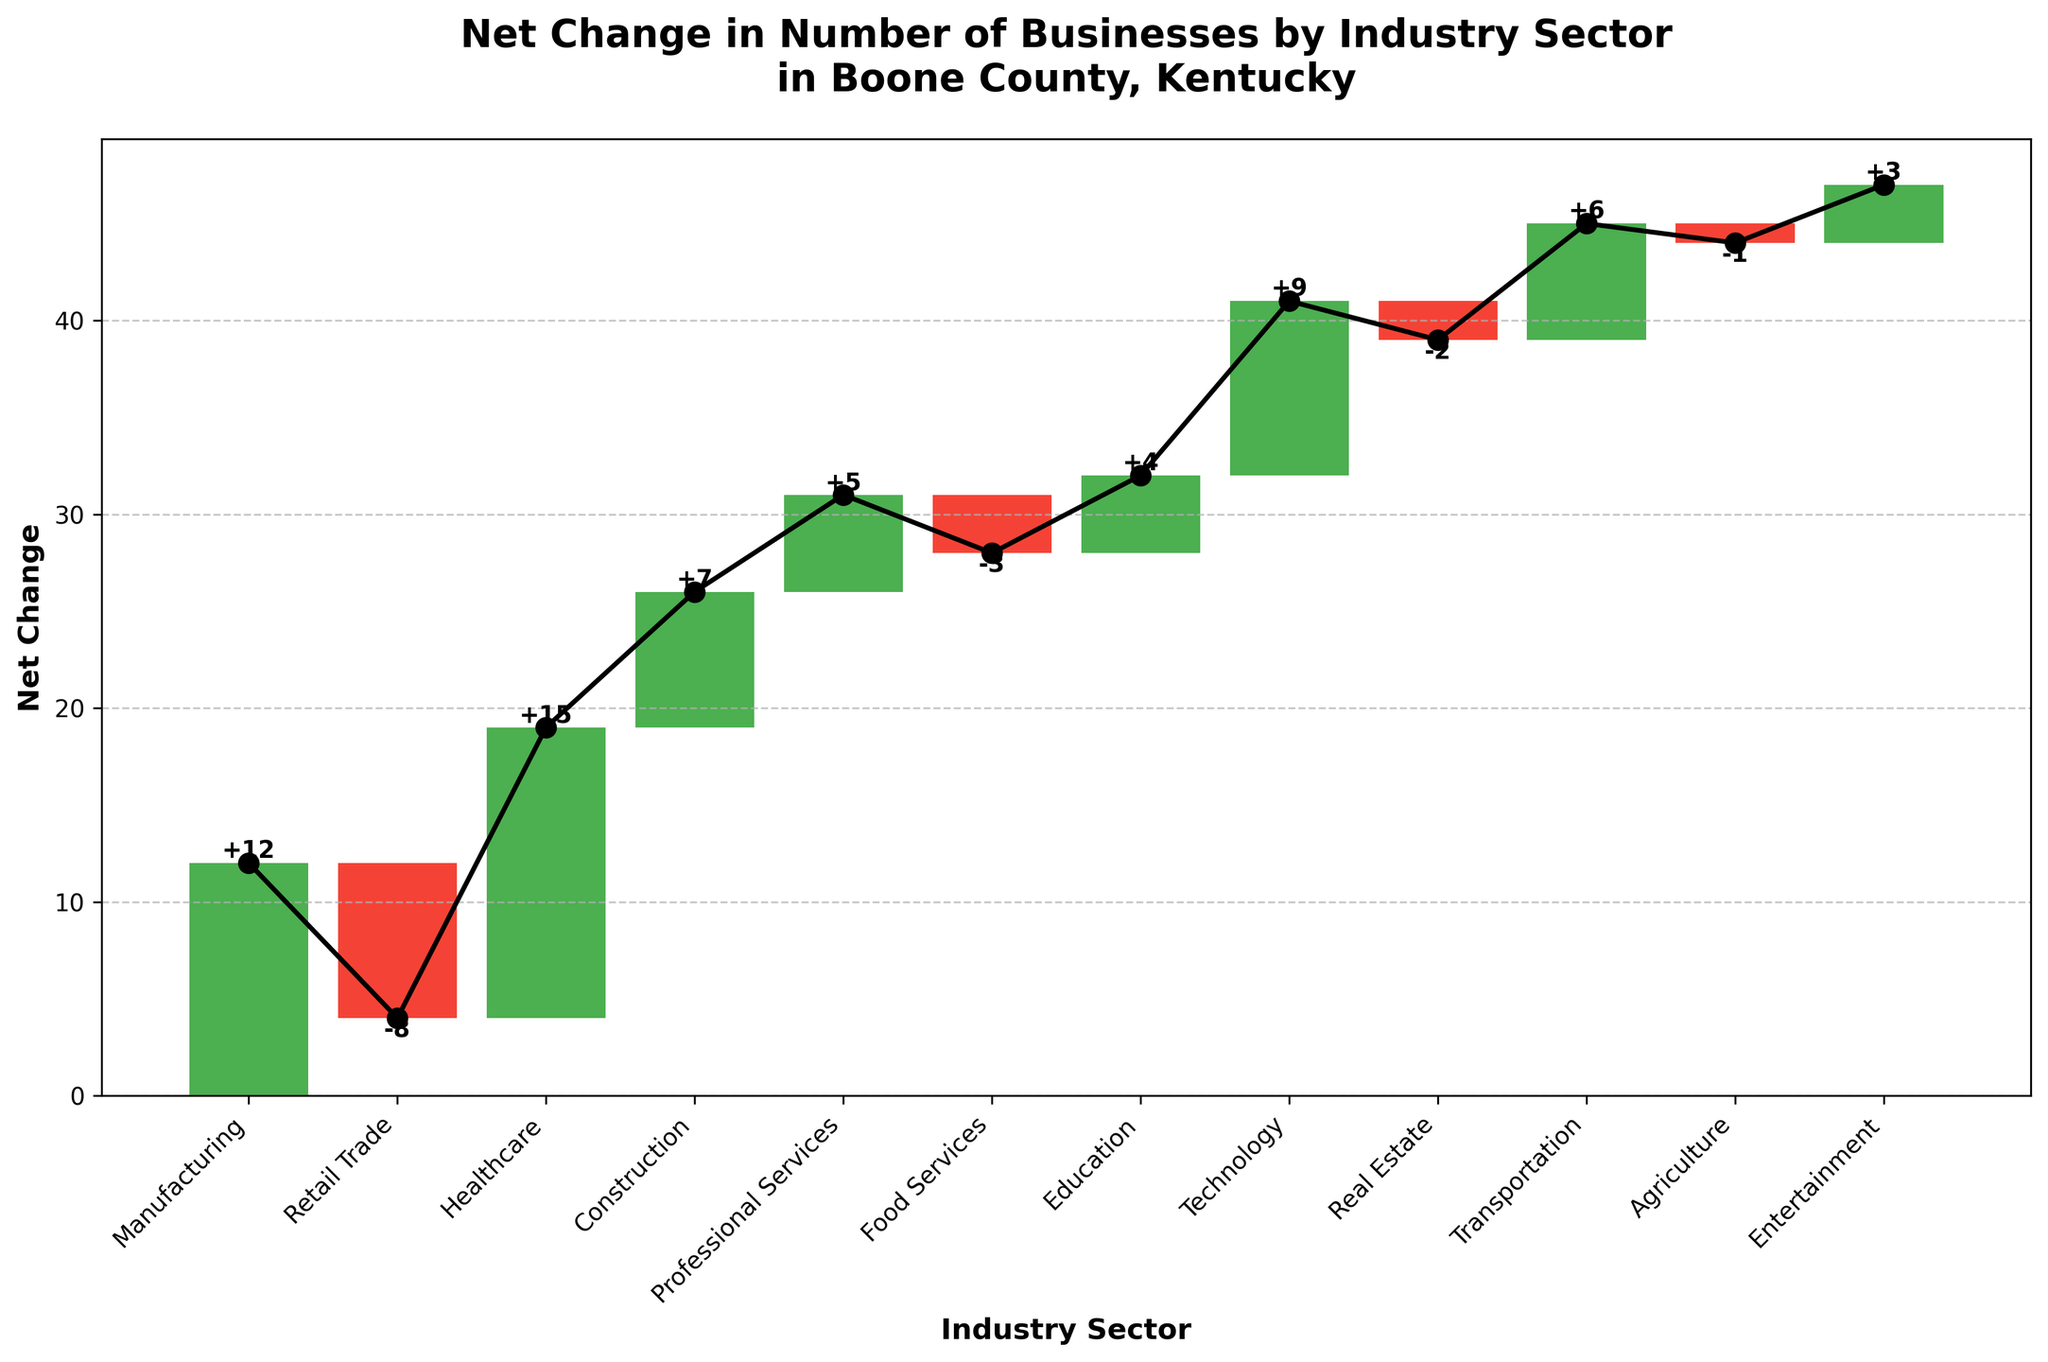What is the title of the chart? The title is usually located at the top of the chart and summarizes the main topic being visualized.
Answer: Net Change in Number of Businesses by Industry Sector in Boone County, Kentucky How many industry sectors experienced a positive net change? To find this, count the number of bars colored in green (indicating a positive net change).
Answer: 8 Which industry sector had the largest negative net change? Look for the red bar with the smallest value. In this case, it is the bar for Retail Trade with -8.
Answer: Retail Trade What is the cumulative net change by the end of the chart? The cumulative net change is shown by the last point on the line plot connecting the tops of the bars.
Answer: 47 How does the net change in Technology compare to that in Construction? Compare the heights of the bars for Technology and Construction. Technology has a higher bar (9) compared to Construction (7).
Answer: Technology has a higher net change Which industry sector saw a net change of 15? Look for the bar that is labeled with a value of 15. This bar represents Healthcare.
Answer: Healthcare What is the total net change for the first three industry sectors? Sum the net changes for Manufacturing, Retail Trade, and Healthcare: 12 + (-8) + 15 = 19.
Answer: 19 Which industry sector has the smallest decrease? Identify the sectors with a negative net change and find the one with the smallest absolute value. Agriculture has a net change of -1.
Answer: Agriculture What is the net change difference between Entertainment and Education? Subtract the net change of Entertainment from that of Education: 4 - 3 = 1.
Answer: 1 How many industry sectors showed a net change of exactly 5 or more? Count the number of bars that are labeled with a value of 5 or more. In this case, they are Manufacturing, Healthcare, Technology, Construction, and Transportation.
Answer: 5 